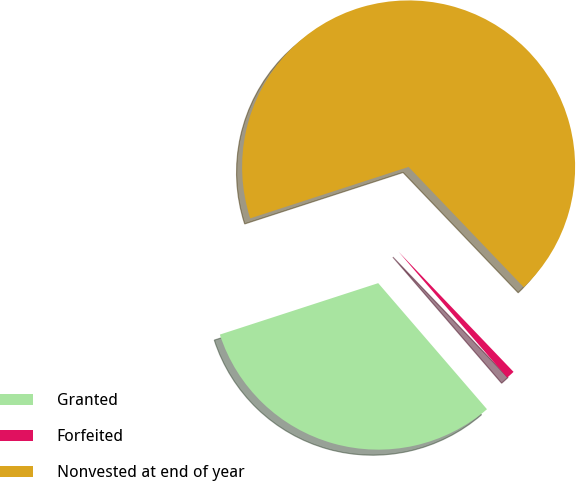Convert chart. <chart><loc_0><loc_0><loc_500><loc_500><pie_chart><fcel>Granted<fcel>Forfeited<fcel>Nonvested at end of year<nl><fcel>31.33%<fcel>0.82%<fcel>67.85%<nl></chart> 